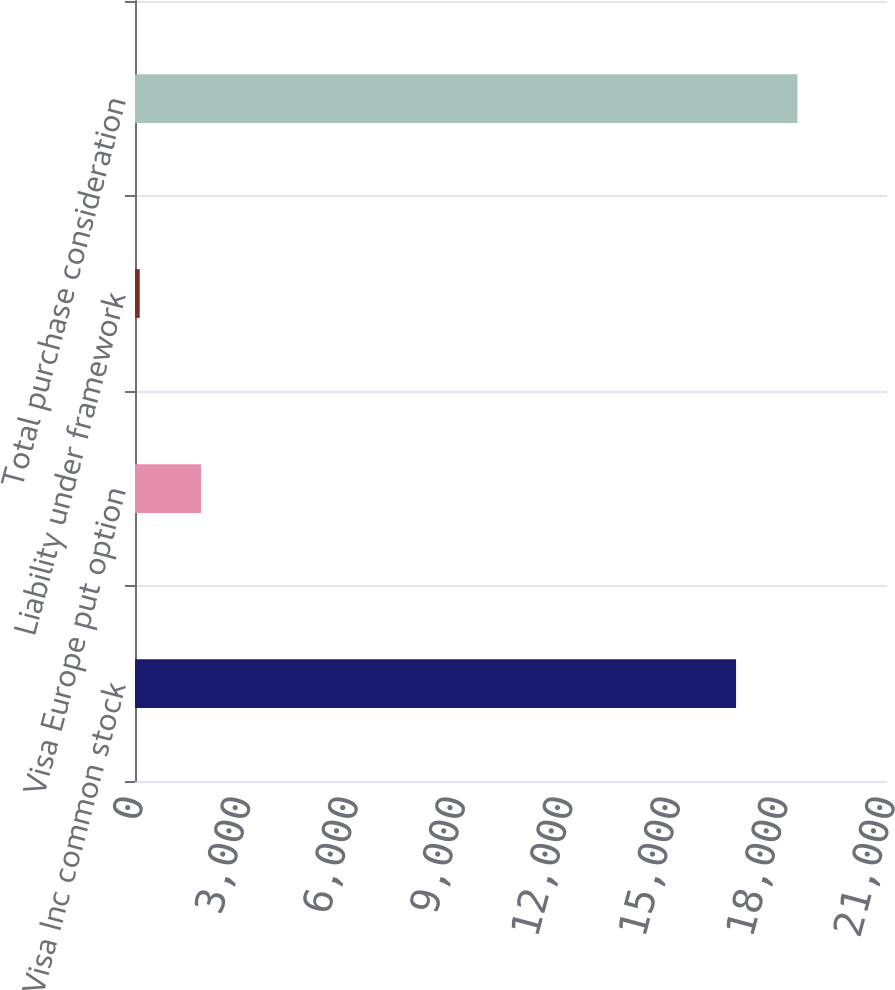Convert chart to OTSL. <chart><loc_0><loc_0><loc_500><loc_500><bar_chart><fcel>Visa Inc common stock<fcel>Visa Europe put option<fcel>Liability under framework<fcel>Total purchase consideration<nl><fcel>16785<fcel>1845.1<fcel>132<fcel>18498.1<nl></chart> 